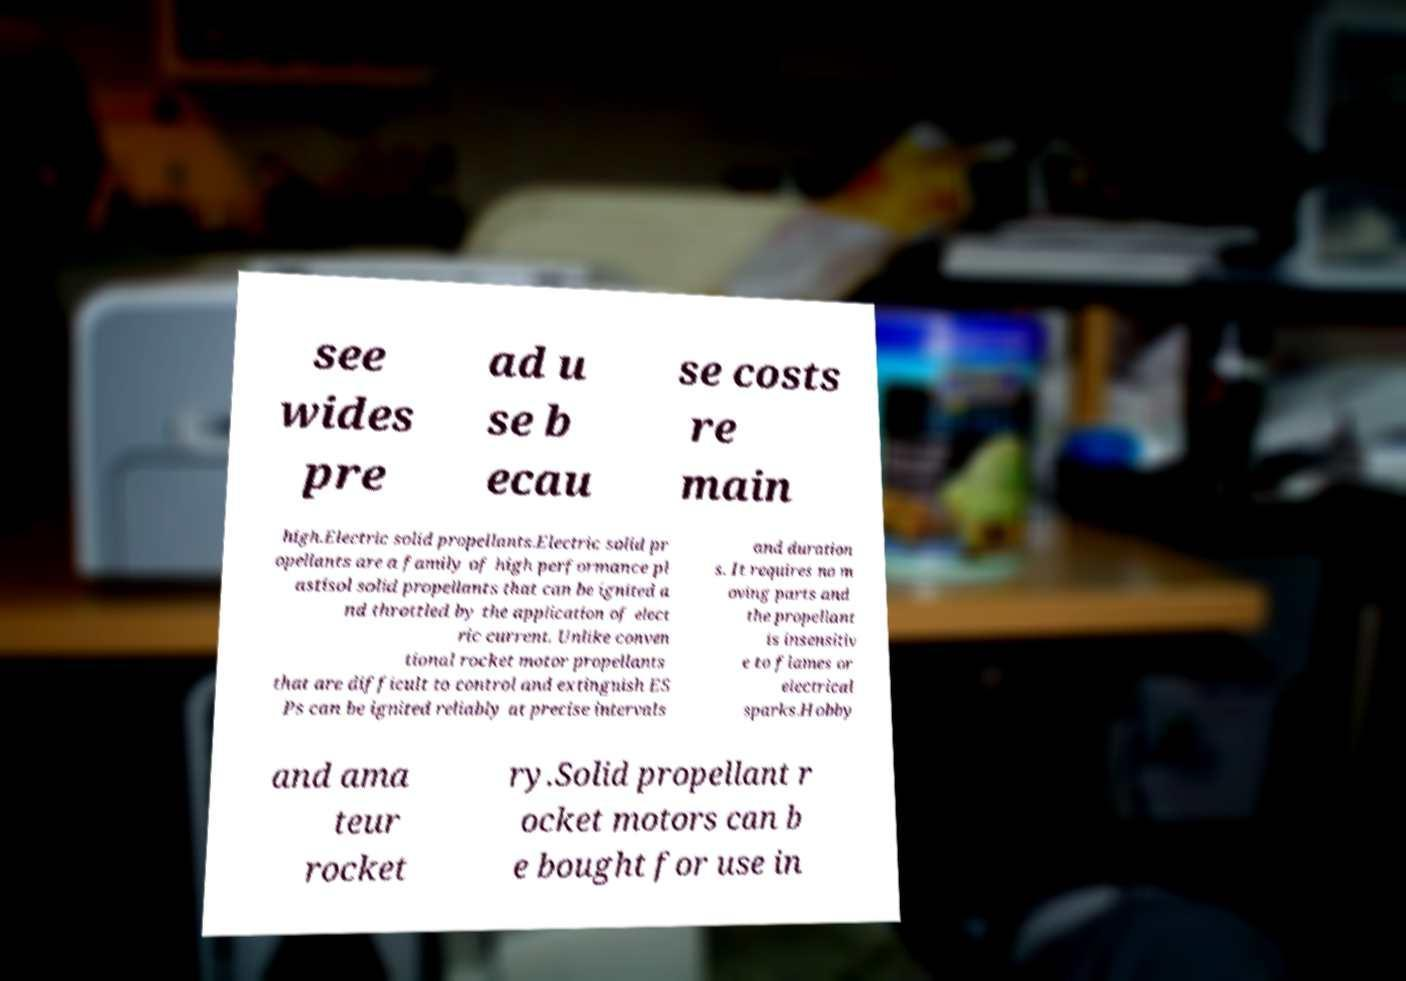Can you read and provide the text displayed in the image?This photo seems to have some interesting text. Can you extract and type it out for me? see wides pre ad u se b ecau se costs re main high.Electric solid propellants.Electric solid pr opellants are a family of high performance pl astisol solid propellants that can be ignited a nd throttled by the application of elect ric current. Unlike conven tional rocket motor propellants that are difficult to control and extinguish ES Ps can be ignited reliably at precise intervals and duration s. It requires no m oving parts and the propellant is insensitiv e to flames or electrical sparks.Hobby and ama teur rocket ry.Solid propellant r ocket motors can b e bought for use in 